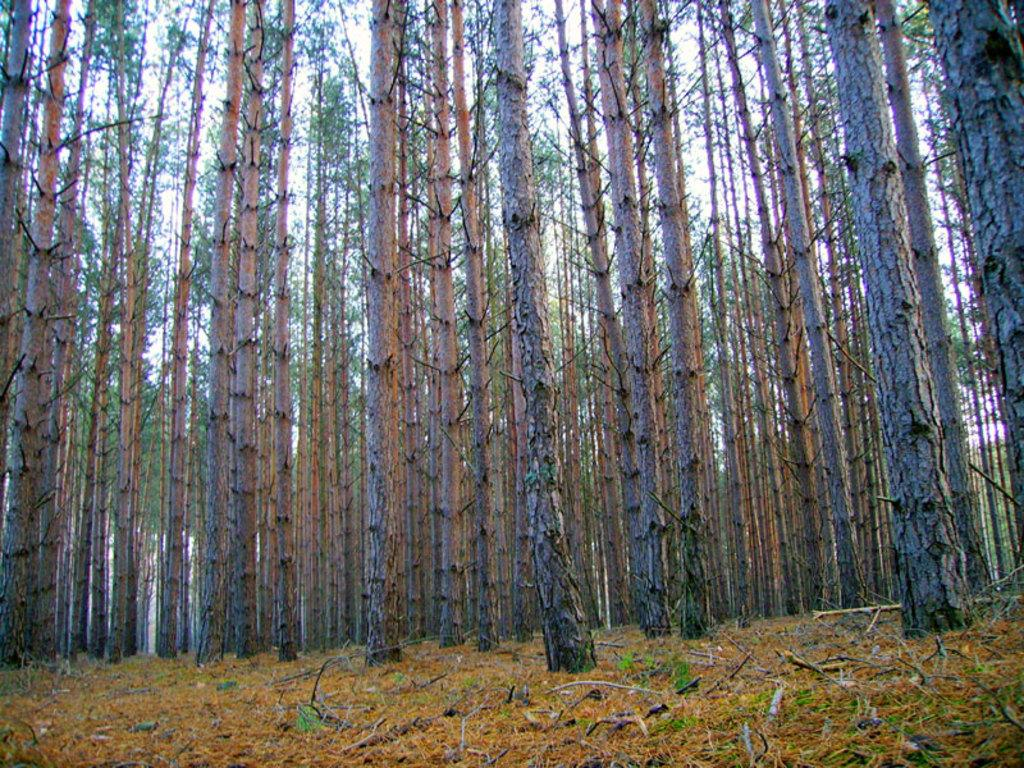What type of landscape is depicted in the image? There is dry grassland in the image. What can be seen in the distance in the image? There are trees in the background of the image. What is visible above the grassland and trees in the image? The sky is visible in the background of the image. How many inventions can be seen in the image? There are no inventions present in the image; it features a landscape with dry grassland, trees, and the sky. What type of bean is growing in the image? There are no beans present in the image; it features a landscape with dry grassland, trees, and the sky. 